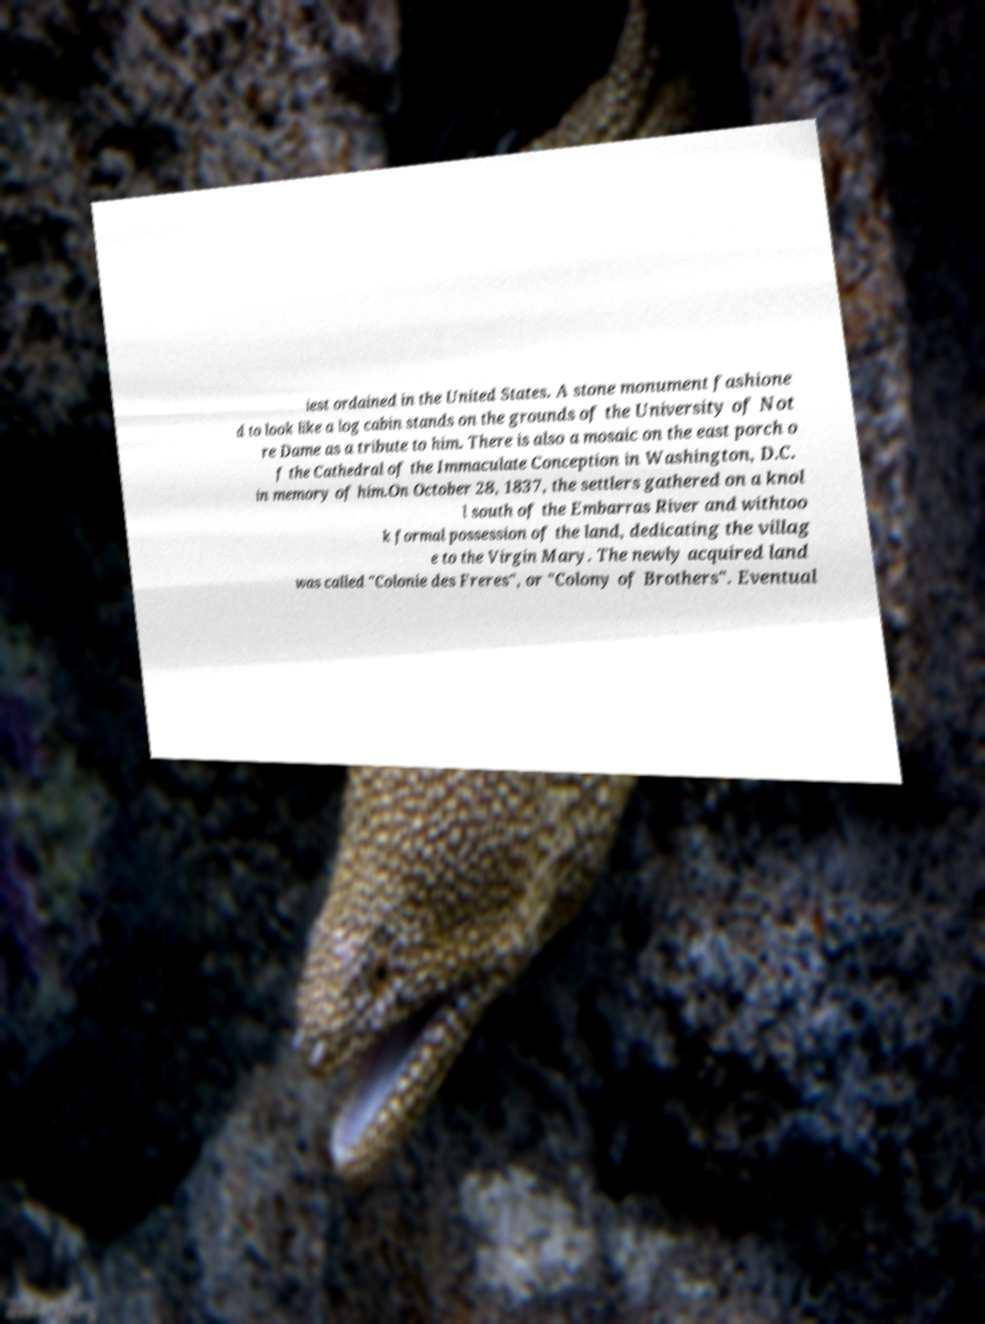There's text embedded in this image that I need extracted. Can you transcribe it verbatim? iest ordained in the United States. A stone monument fashione d to look like a log cabin stands on the grounds of the University of Not re Dame as a tribute to him. There is also a mosaic on the east porch o f the Cathedral of the Immaculate Conception in Washington, D.C. in memory of him.On October 28, 1837, the settlers gathered on a knol l south of the Embarras River and withtoo k formal possession of the land, dedicating the villag e to the Virgin Mary. The newly acquired land was called "Colonie des Freres", or "Colony of Brothers". Eventual 